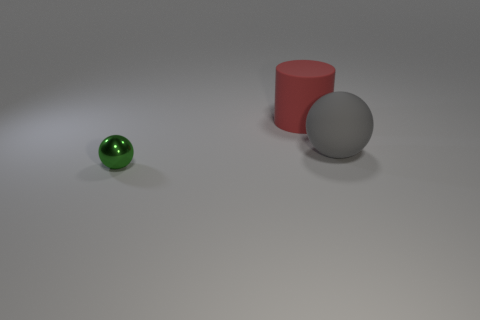What can you infer about the setting or context based on the image? The image seems to represent a simple and controlled environment, likely set up for the purpose of a visual demonstration or an artistic composition. The neutral background and lack of any additional items suggest that the focus is on the shapes, sizes, and materials of the objects themselves. 